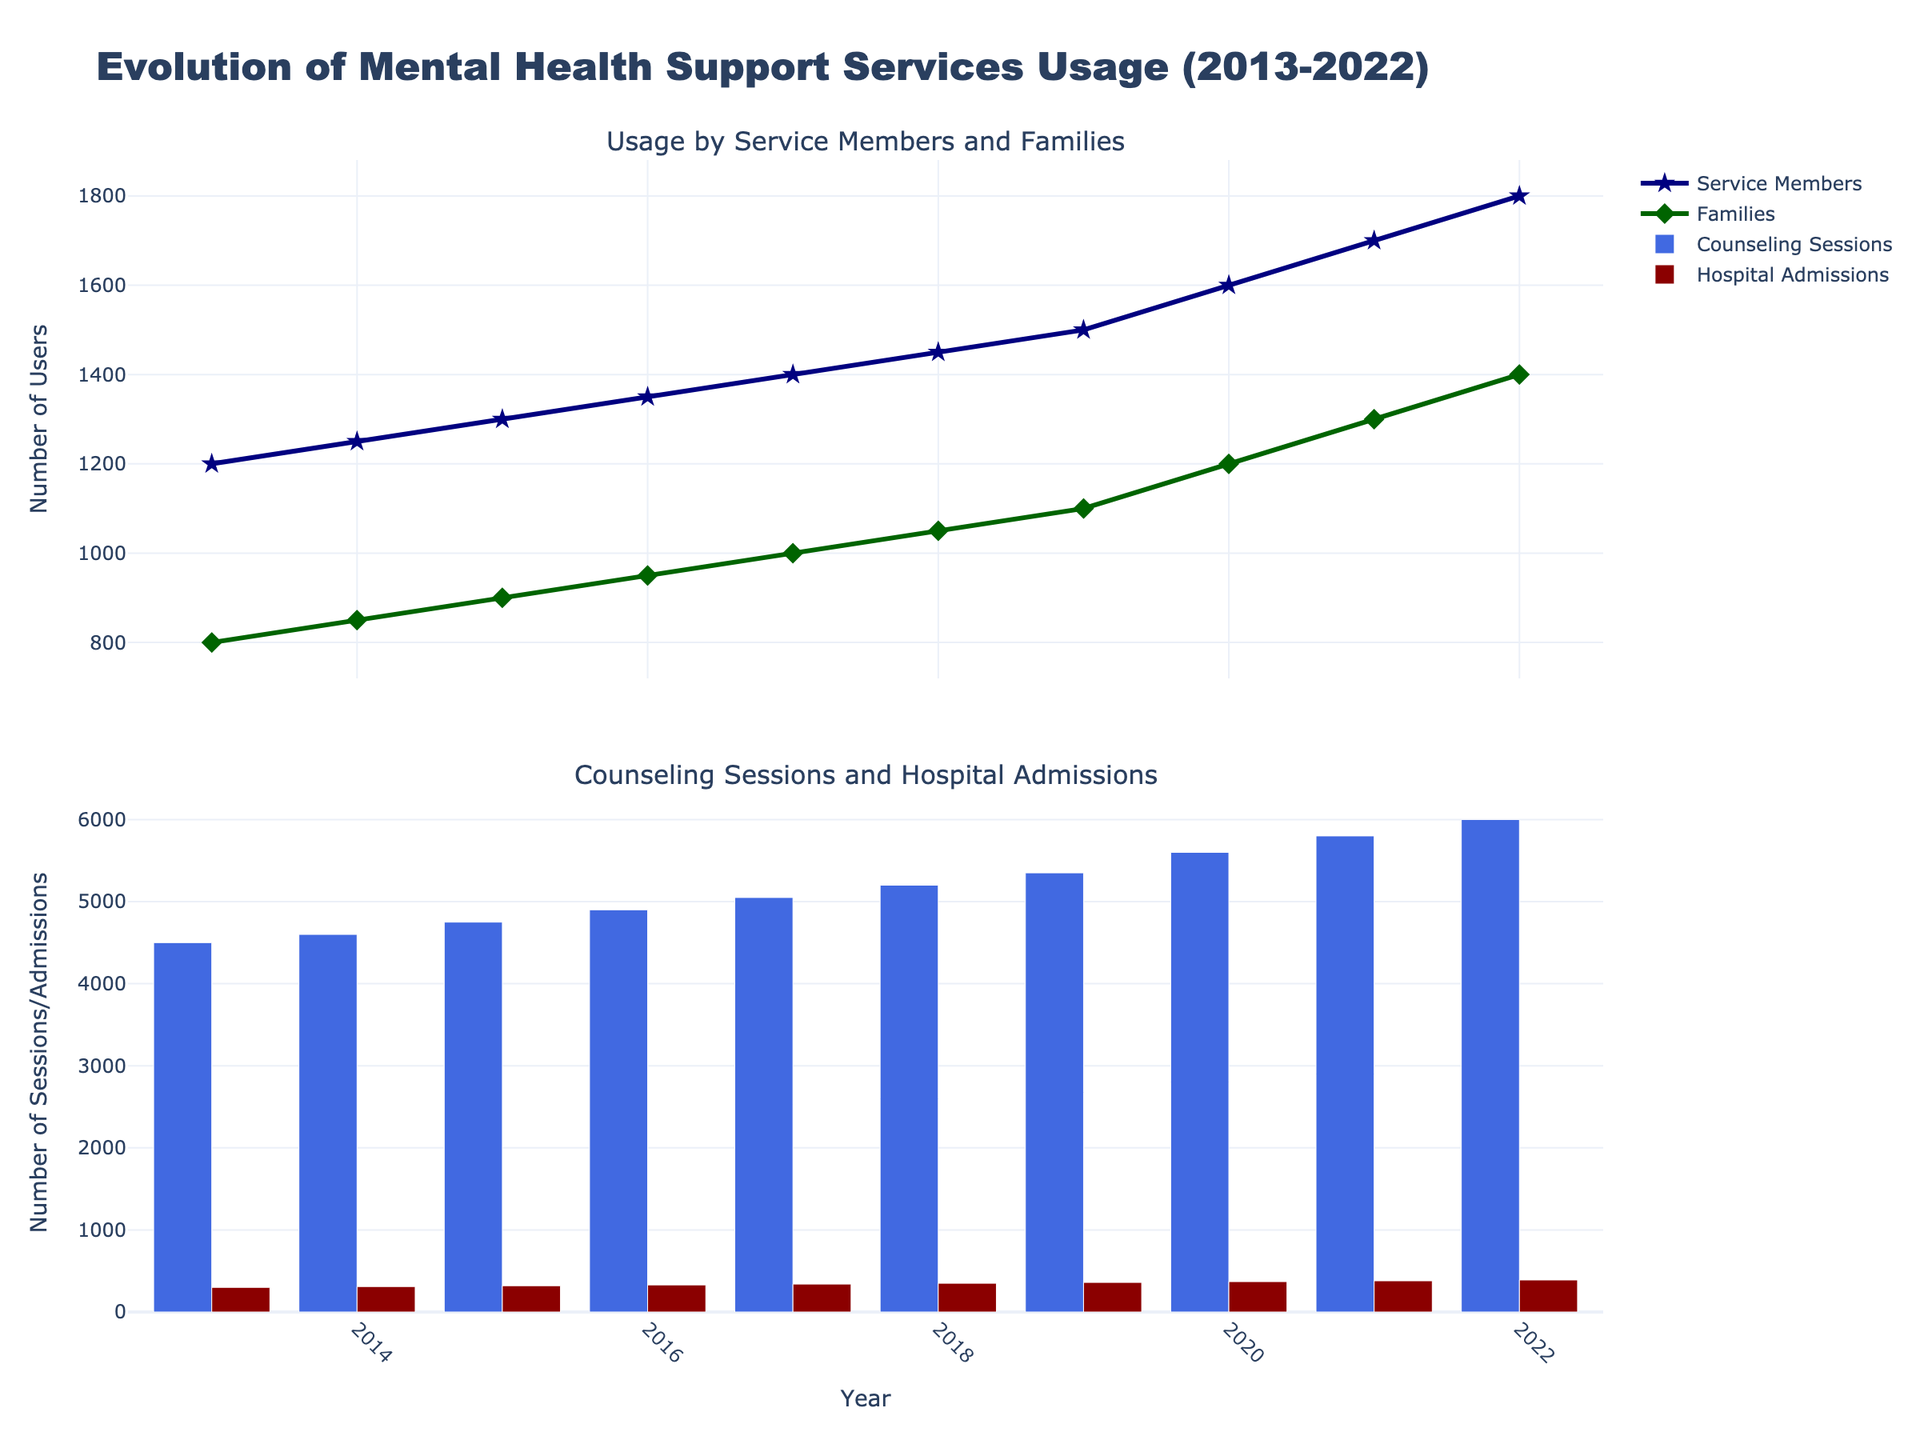What is the title of the figure? The title of the figure is clearly displayed at the top of the plot.
Answer: Evolution of Mental Health Support Services Usage (2013-2022) How many subplots are present in the figure? The figure is divided into different sections where data is visualized, and there are specific titles for each section that denote this separation.
Answer: 2 What color represents "Hospital Admissions"? The color for "Hospital Admissions" can be determined by looking at the corresponding bar in the plot and the legend.
Answer: Dark red How did the usage of Mental Health Support Services by service members change from 2013 to 2022? By observing the line that represents "Service Members" and its change from 2013 to 2022, we can see whether it increased, decreased, or remained constant.
Answer: Increased What is the difference between the number of counseling sessions and hospital admissions in 2022? To find the difference, subtract the number of hospital admissions from the number of counseling sessions for the year 2022.
Answer: 5610 In which year did families' usage of mental health services reach 1200? The specific year can be identified by finding the point on the "Families Usage" line where the y-axis reaches 1200.
Answer: 2020 By how much did the number of hospital admissions increase from 2013 to 2022? To calculate the increase, subtract the number of hospital admissions in 2013 from the number in 2022.
Answer: 90 Which had the highest number in 2019: Counseling Sessions or Hospital Admissions? Compare the values of both categories in 2019 by looking at the heights of the respective bars.
Answer: Counseling Sessions Which year saw the highest number of service members using the mental health support services? The peak point on the "Service Members Usage" line graph indicates the year with the highest usage.
Answer: 2022 